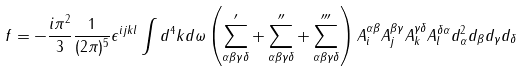Convert formula to latex. <formula><loc_0><loc_0><loc_500><loc_500>f = - \frac { i \pi ^ { 2 } } { 3 } \frac { 1 } { ( 2 \pi ) ^ { 5 } } \epsilon ^ { i j k l } \int d ^ { 4 } k d \omega \left ( \sum _ { \alpha \beta \gamma \delta } ^ { \prime } + \sum _ { \alpha \beta \gamma \delta } ^ { \prime \prime } + \sum _ { \alpha \beta \gamma \delta } ^ { \prime \prime \prime } \right ) A ^ { \alpha \beta } _ { i } A _ { j } ^ { \beta \gamma } A _ { k } ^ { \gamma \delta } A _ { l } ^ { \delta \alpha } d _ { \alpha } ^ { 2 } d _ { \beta } d _ { \gamma } d _ { \delta }</formula> 